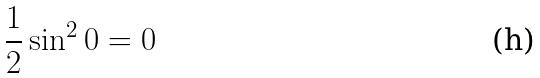Convert formula to latex. <formula><loc_0><loc_0><loc_500><loc_500>\frac { 1 } { 2 } \sin ^ { 2 } 0 = 0</formula> 